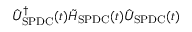<formula> <loc_0><loc_0><loc_500><loc_500>\hat { U } _ { S P D C } ^ { \dagger } ( t ) \tilde { H } _ { S P D C } ( t ) \hat { U } _ { S P D C } ( t )</formula> 